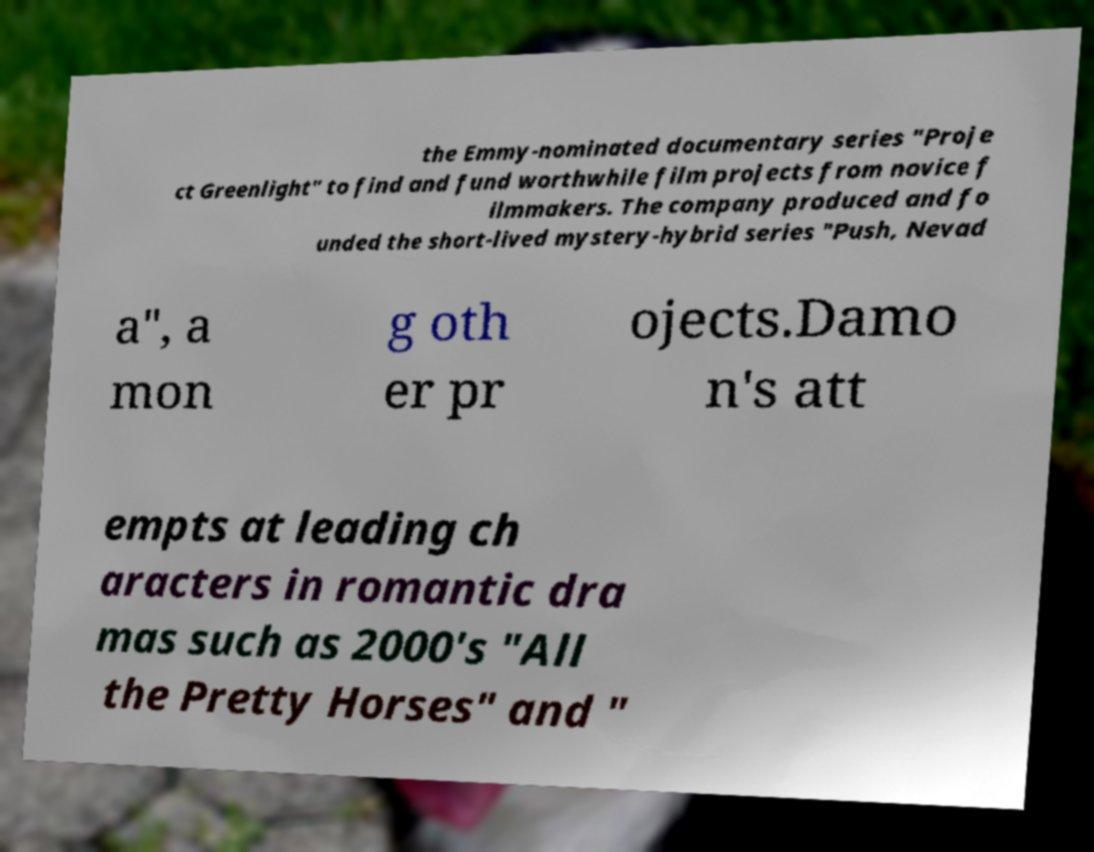Can you read and provide the text displayed in the image?This photo seems to have some interesting text. Can you extract and type it out for me? the Emmy-nominated documentary series "Proje ct Greenlight" to find and fund worthwhile film projects from novice f ilmmakers. The company produced and fo unded the short-lived mystery-hybrid series "Push, Nevad a", a mon g oth er pr ojects.Damo n's att empts at leading ch aracters in romantic dra mas such as 2000's "All the Pretty Horses" and " 